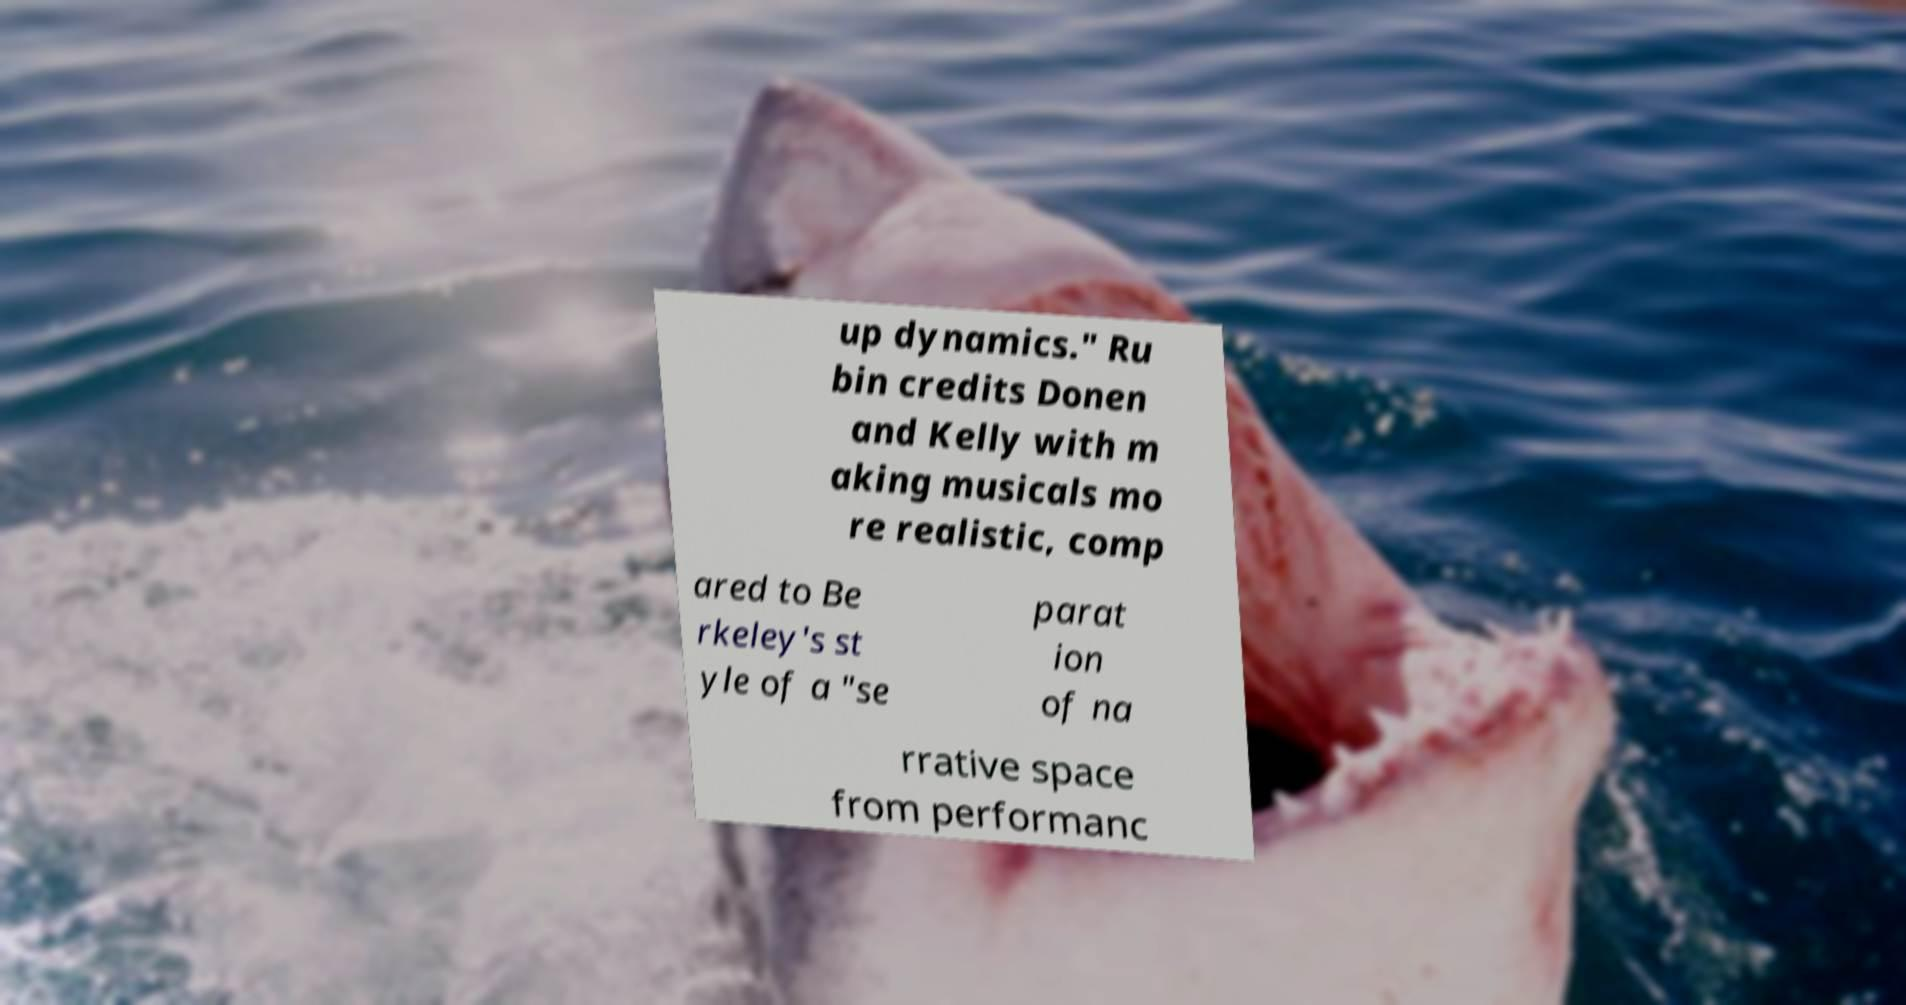For documentation purposes, I need the text within this image transcribed. Could you provide that? up dynamics." Ru bin credits Donen and Kelly with m aking musicals mo re realistic, comp ared to Be rkeley's st yle of a "se parat ion of na rrative space from performanc 